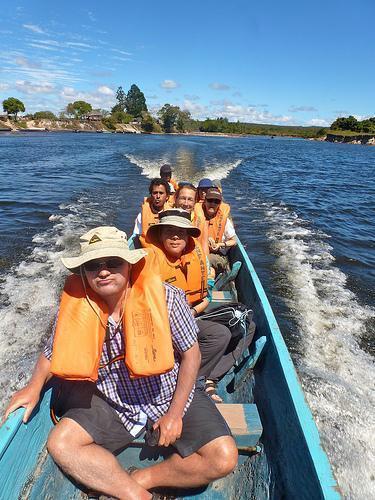How many people have hats on?
Give a very brief answer. 5. 